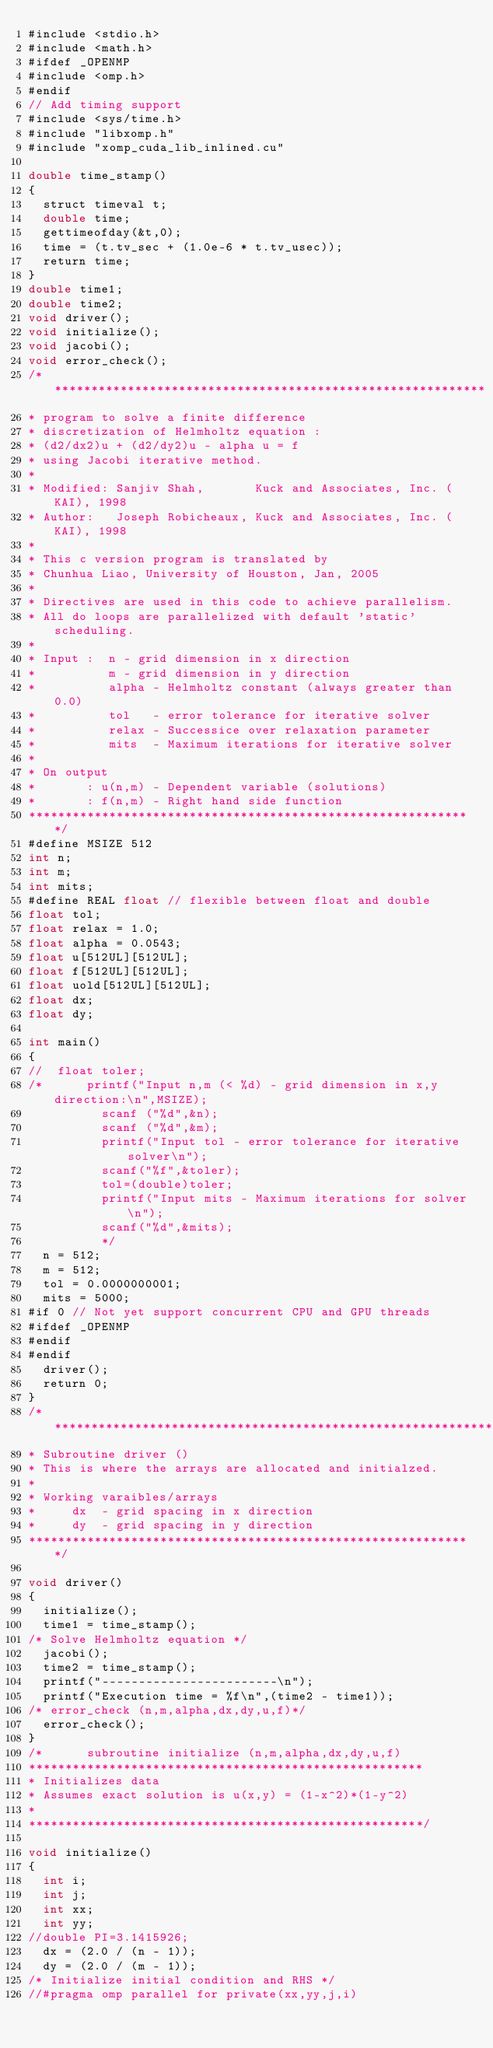<code> <loc_0><loc_0><loc_500><loc_500><_Cuda_>#include <stdio.h>
#include <math.h>
#ifdef _OPENMP
#include <omp.h>
#endif
// Add timing support
#include <sys/time.h>
#include "libxomp.h" 
#include "xomp_cuda_lib_inlined.cu" 

double time_stamp()
{
  struct timeval t;
  double time;
  gettimeofday(&t,0);
  time = (t.tv_sec + (1.0e-6 * t.tv_usec));
  return time;
}
double time1;
double time2;
void driver();
void initialize();
void jacobi();
void error_check();
/************************************************************
* program to solve a finite difference 
* discretization of Helmholtz equation :  
* (d2/dx2)u + (d2/dy2)u - alpha u = f 
* using Jacobi iterative method. 
*
* Modified: Sanjiv Shah,       Kuck and Associates, Inc. (KAI), 1998
* Author:   Joseph Robicheaux, Kuck and Associates, Inc. (KAI), 1998
*
* This c version program is translated by 
* Chunhua Liao, University of Houston, Jan, 2005 
* 
* Directives are used in this code to achieve parallelism. 
* All do loops are parallelized with default 'static' scheduling.
* 
* Input :  n - grid dimension in x direction 
*          m - grid dimension in y direction
*          alpha - Helmholtz constant (always greater than 0.0)
*          tol   - error tolerance for iterative solver
*          relax - Successice over relaxation parameter
*          mits  - Maximum iterations for iterative solver
*
* On output 
*       : u(n,m) - Dependent variable (solutions)
*       : f(n,m) - Right hand side function 
*************************************************************/
#define MSIZE 512
int n;
int m;
int mits;
#define REAL float // flexible between float and double
float tol;
float relax = 1.0;
float alpha = 0.0543;
float u[512UL][512UL];
float f[512UL][512UL];
float uold[512UL][512UL];
float dx;
float dy;

int main()
{
//  float toler;
/*      printf("Input n,m (< %d) - grid dimension in x,y direction:\n",MSIZE); 
          scanf ("%d",&n);
          scanf ("%d",&m);
          printf("Input tol - error tolerance for iterative solver\n"); 
          scanf("%f",&toler);
          tol=(double)toler;
          printf("Input mits - Maximum iterations for solver\n"); 
          scanf("%d",&mits);
          */
  n = 512;
  m = 512;
  tol = 0.0000000001;
  mits = 5000;
#if 0 // Not yet support concurrent CPU and GPU threads  
#ifdef _OPENMP
#endif
#endif  
  driver();
  return 0;
}
/*************************************************************
* Subroutine driver () 
* This is where the arrays are allocated and initialzed. 
*
* Working varaibles/arrays 
*     dx  - grid spacing in x direction 
*     dy  - grid spacing in y direction 
*************************************************************/

void driver()
{
  initialize();
  time1 = time_stamp();
/* Solve Helmholtz equation */
  jacobi();
  time2 = time_stamp();
  printf("------------------------\n");
  printf("Execution time = %f\n",(time2 - time1));
/* error_check (n,m,alpha,dx,dy,u,f)*/
  error_check();
}
/*      subroutine initialize (n,m,alpha,dx,dy,u,f) 
******************************************************
* Initializes data 
* Assumes exact solution is u(x,y) = (1-x^2)*(1-y^2)
*
******************************************************/

void initialize()
{
  int i;
  int j;
  int xx;
  int yy;
//double PI=3.1415926;
  dx = (2.0 / (n - 1));
  dy = (2.0 / (m - 1));
/* Initialize initial condition and RHS */
//#pragma omp parallel for private(xx,yy,j,i)</code> 